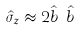<formula> <loc_0><loc_0><loc_500><loc_500>\hat { \sigma } _ { z } \approx 2 \hat { b } ^ { \dagger } \hat { b }</formula> 